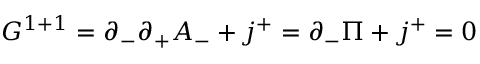Convert formula to latex. <formula><loc_0><loc_0><loc_500><loc_500>G ^ { 1 + 1 } = \partial _ { - } \partial _ { + } A _ { - } + j ^ { + } = \partial _ { - } \Pi + j ^ { + } = 0</formula> 